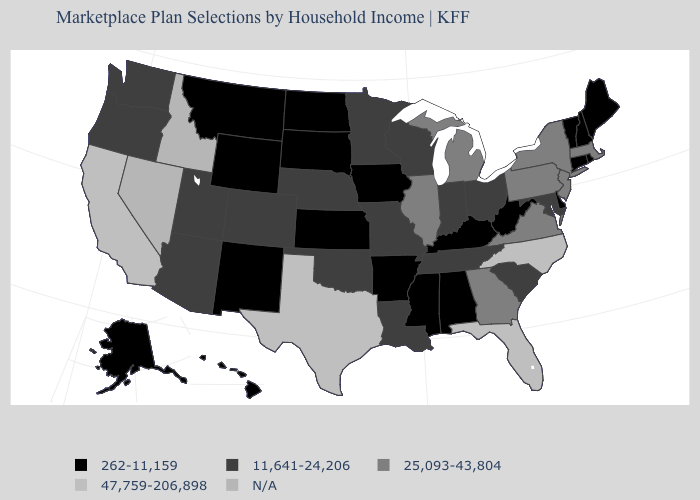What is the value of Maine?
Short answer required. 262-11,159. What is the value of New Hampshire?
Quick response, please. 262-11,159. Among the states that border Rhode Island , which have the highest value?
Give a very brief answer. Massachusetts. Name the states that have a value in the range 11,641-24,206?
Short answer required. Arizona, Colorado, Indiana, Louisiana, Maryland, Minnesota, Missouri, Nebraska, Ohio, Oklahoma, Oregon, South Carolina, Tennessee, Utah, Washington, Wisconsin. What is the highest value in the USA?
Answer briefly. 47,759-206,898. What is the value of New Jersey?
Be succinct. 25,093-43,804. Which states have the lowest value in the USA?
Quick response, please. Alabama, Alaska, Arkansas, Connecticut, Delaware, Hawaii, Iowa, Kansas, Kentucky, Maine, Mississippi, Montana, New Hampshire, New Mexico, North Dakota, Rhode Island, South Dakota, Vermont, West Virginia, Wyoming. Name the states that have a value in the range 25,093-43,804?
Answer briefly. Georgia, Illinois, Massachusetts, Michigan, New Jersey, New York, Pennsylvania, Virginia. Name the states that have a value in the range 11,641-24,206?
Answer briefly. Arizona, Colorado, Indiana, Louisiana, Maryland, Minnesota, Missouri, Nebraska, Ohio, Oklahoma, Oregon, South Carolina, Tennessee, Utah, Washington, Wisconsin. Name the states that have a value in the range N/A?
Concise answer only. Idaho, Nevada. Does the first symbol in the legend represent the smallest category?
Answer briefly. Yes. Does Pennsylvania have the lowest value in the Northeast?
Concise answer only. No. Name the states that have a value in the range 11,641-24,206?
Be succinct. Arizona, Colorado, Indiana, Louisiana, Maryland, Minnesota, Missouri, Nebraska, Ohio, Oklahoma, Oregon, South Carolina, Tennessee, Utah, Washington, Wisconsin. Among the states that border Michigan , which have the lowest value?
Concise answer only. Indiana, Ohio, Wisconsin. 